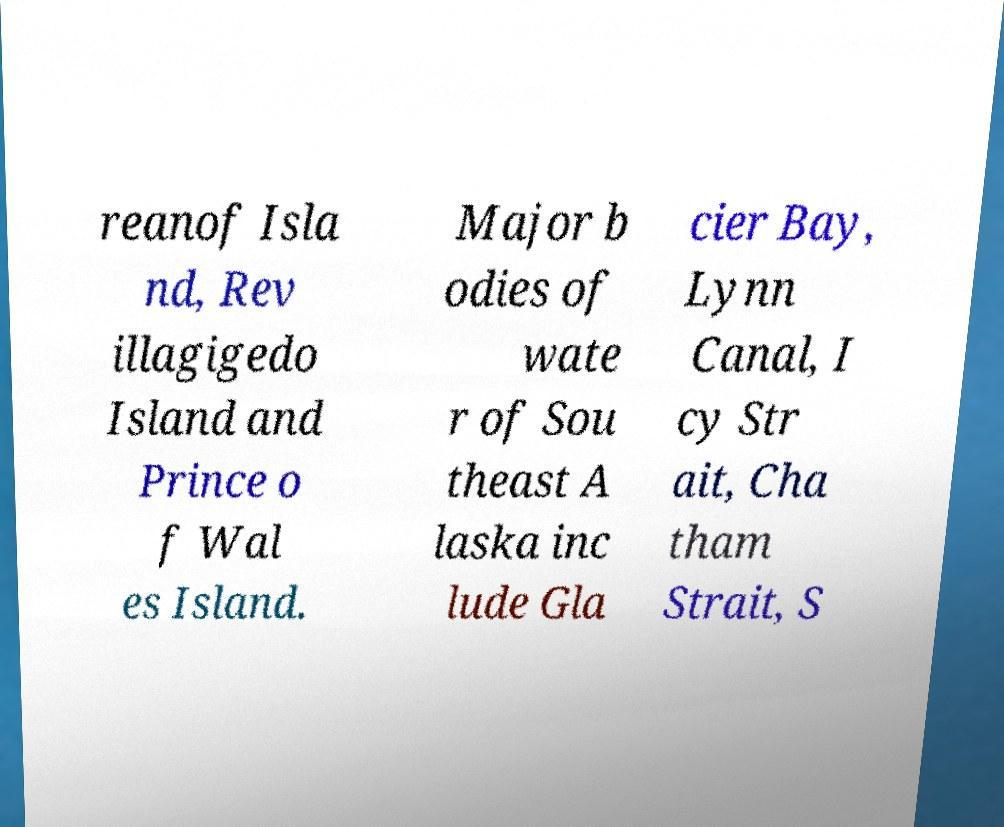Can you accurately transcribe the text from the provided image for me? reanof Isla nd, Rev illagigedo Island and Prince o f Wal es Island. Major b odies of wate r of Sou theast A laska inc lude Gla cier Bay, Lynn Canal, I cy Str ait, Cha tham Strait, S 